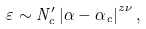Convert formula to latex. <formula><loc_0><loc_0><loc_500><loc_500>\varepsilon \sim N _ { c } ^ { \prime } \left | \alpha - \alpha _ { c } \right | ^ { z \nu } ,</formula> 